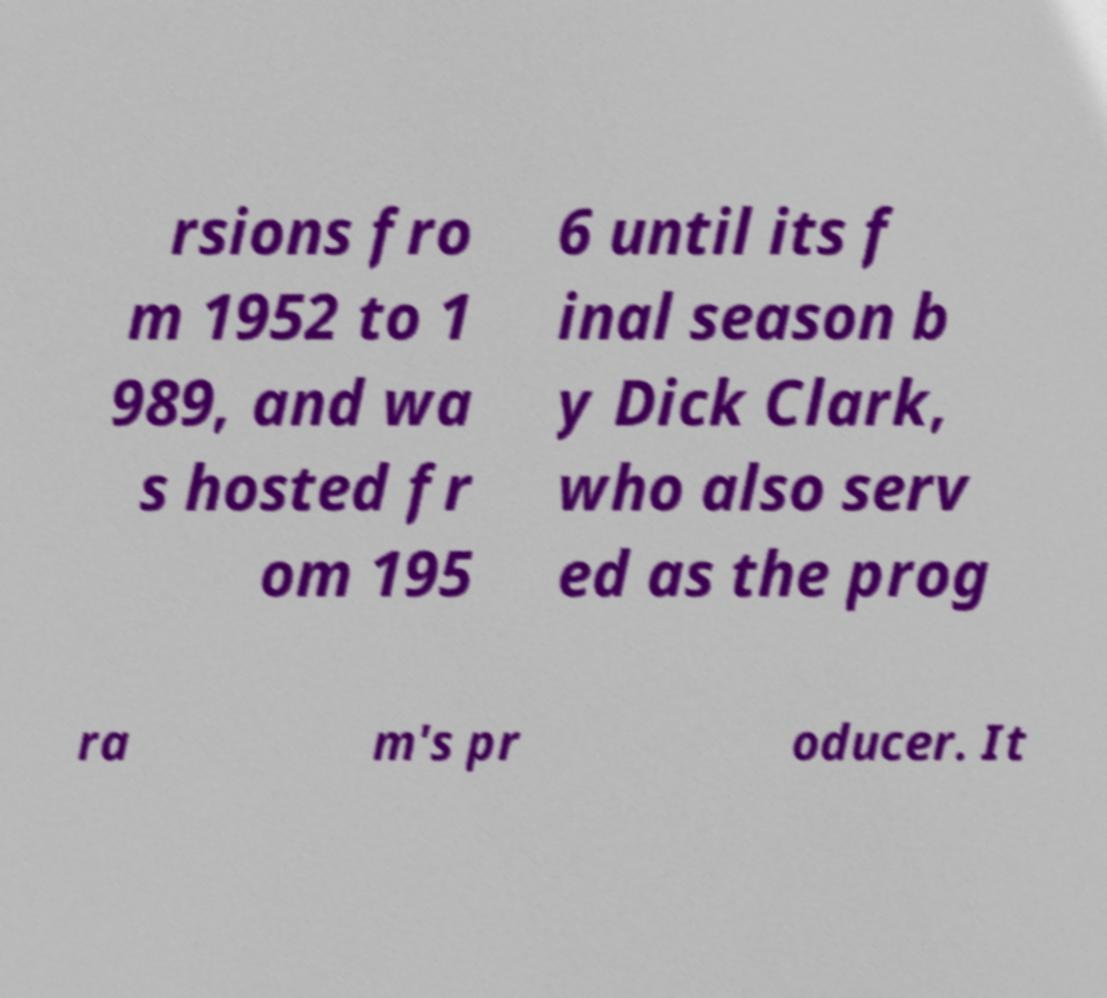Please read and relay the text visible in this image. What does it say? rsions fro m 1952 to 1 989, and wa s hosted fr om 195 6 until its f inal season b y Dick Clark, who also serv ed as the prog ra m's pr oducer. It 